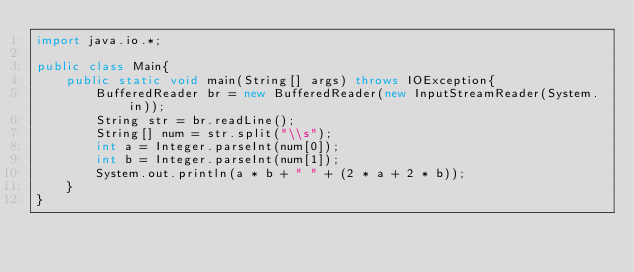<code> <loc_0><loc_0><loc_500><loc_500><_Java_>import java.io.*;

public class Main{
	public static void main(String[] args) throws IOException{
		BufferedReader br = new BufferedReader(new InputStreamReader(System.in));
		String str = br.readLine();
		String[] num = str.split("\\s");
		int a = Integer.parseInt(num[0]);
		int b = Integer.parseInt(num[1]);
		System.out.println(a * b + " " + (2 * a + 2 * b));
	}
}</code> 